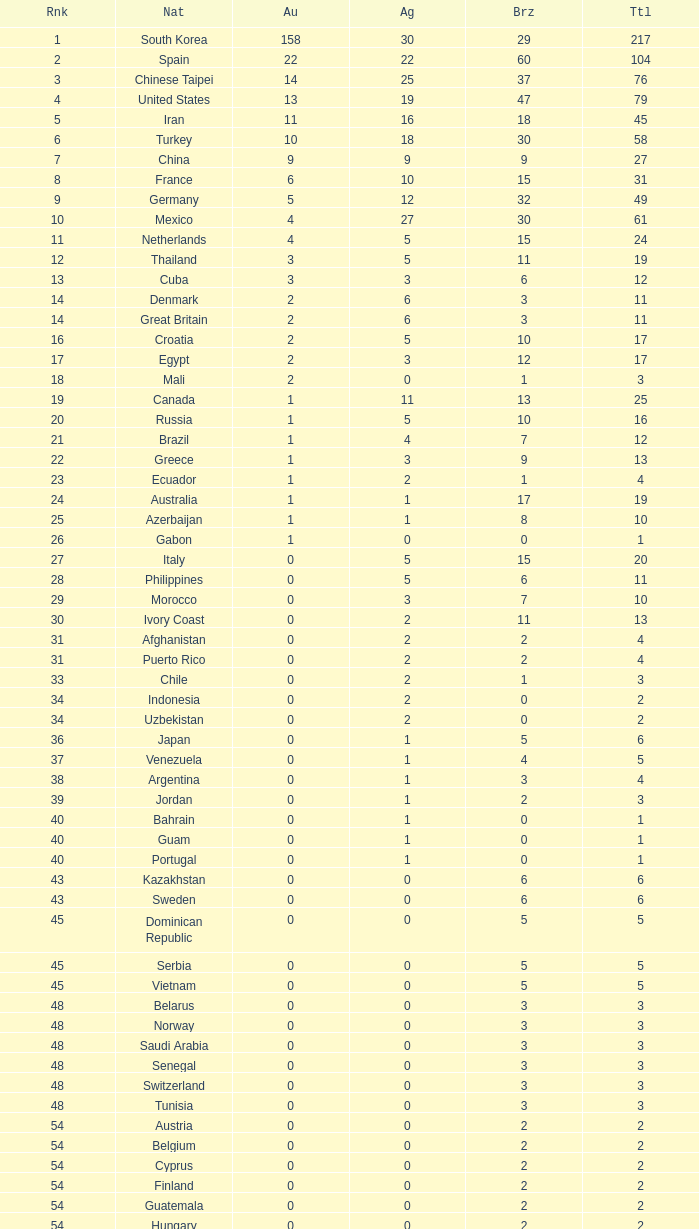What is the Total medals for the Nation ranking 33 with more than 1 Bronze? None. 